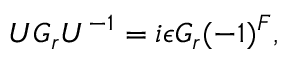Convert formula to latex. <formula><loc_0><loc_0><loc_500><loc_500>U G _ { r } U ^ { - 1 } = i \epsilon G _ { r } ( - 1 ) ^ { F } ,</formula> 